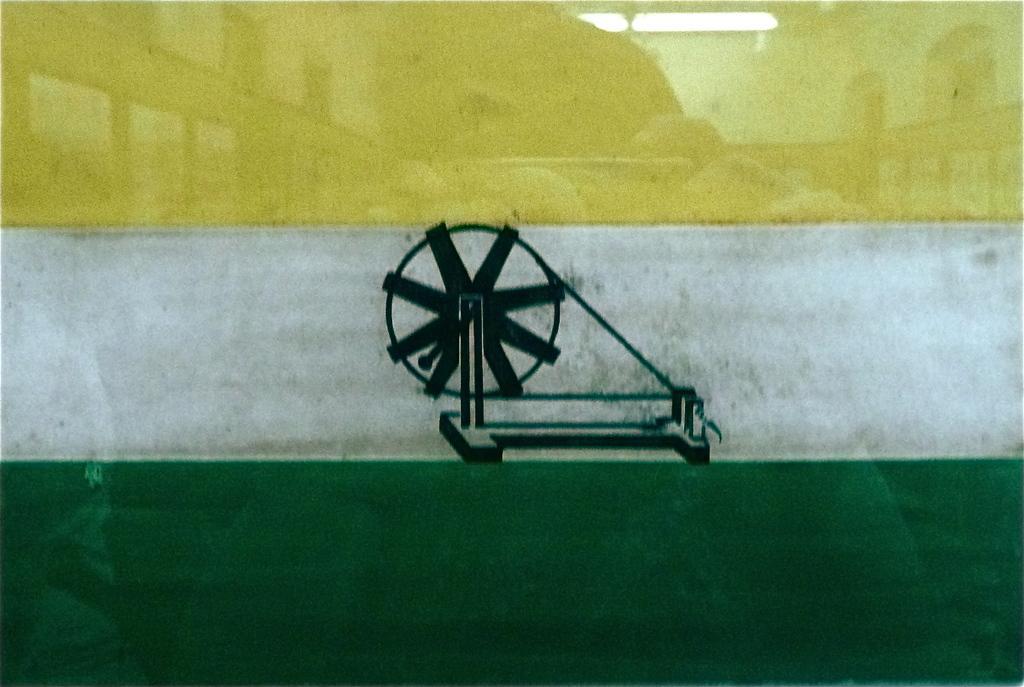Could you give a brief overview of what you see in this image? In this image I can see a tricolor thing and on it I can see depiction of a spinning wheel. 